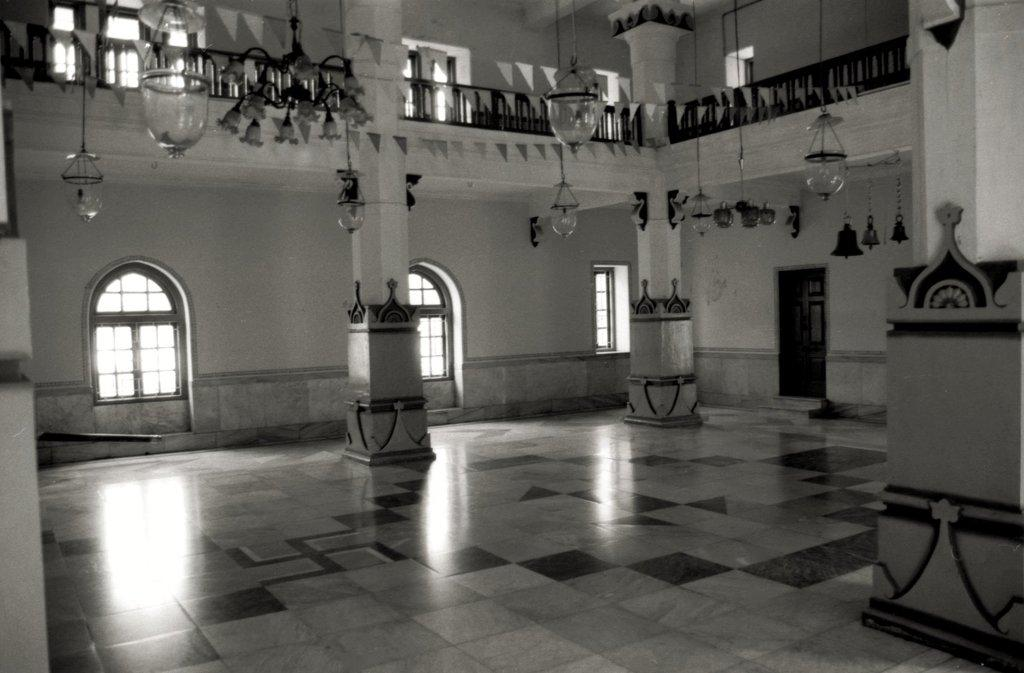What type of location is depicted in the image? The image shows an inside view of a building. What architectural features can be seen in the image? There are windows and a door on the right side of the image. What type of lighting is present in the image? There are lights hanging from the roof. Are there any other objects hanging from the roof? Yes, there are bells hanging bells hanging from the roof. What is the tendency of the mountain in the image to cause loss? There is no mountain present in the image; it shows an inside view of a building with lights and bells hanging from the roof. 